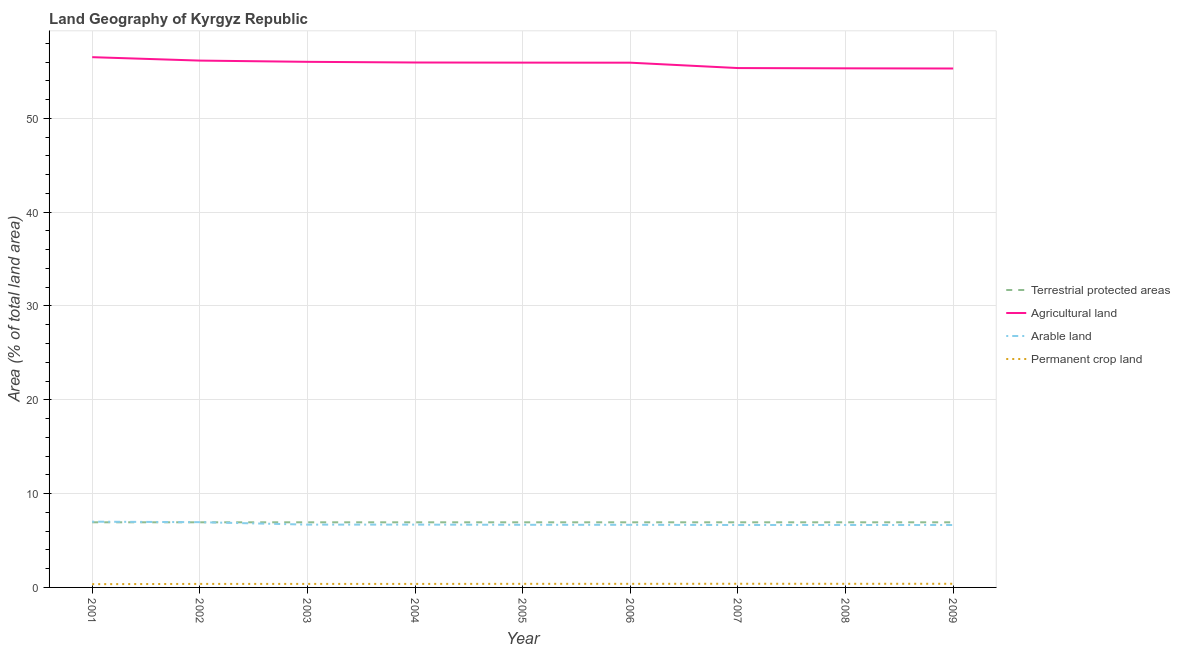How many different coloured lines are there?
Ensure brevity in your answer.  4. Is the number of lines equal to the number of legend labels?
Your response must be concise. Yes. What is the percentage of area under permanent crop land in 2006?
Offer a terse response. 0.38. Across all years, what is the maximum percentage of land under terrestrial protection?
Your answer should be very brief. 6.94. Across all years, what is the minimum percentage of area under arable land?
Your answer should be compact. 6.65. In which year was the percentage of area under permanent crop land maximum?
Make the answer very short. 2007. In which year was the percentage of area under arable land minimum?
Give a very brief answer. 2009. What is the total percentage of land under terrestrial protection in the graph?
Provide a short and direct response. 62.48. What is the difference between the percentage of area under arable land in 2005 and that in 2006?
Keep it short and to the point. 0. What is the difference between the percentage of area under permanent crop land in 2005 and the percentage of area under agricultural land in 2003?
Offer a terse response. -55.64. What is the average percentage of area under agricultural land per year?
Your answer should be compact. 55.83. In the year 2009, what is the difference between the percentage of land under terrestrial protection and percentage of area under arable land?
Your response must be concise. 0.29. In how many years, is the percentage of land under terrestrial protection greater than 18 %?
Offer a terse response. 0. What is the ratio of the percentage of area under arable land in 2001 to that in 2004?
Your answer should be compact. 1.05. Is the percentage of area under arable land in 2002 less than that in 2006?
Provide a succinct answer. No. What is the difference between the highest and the second highest percentage of land under terrestrial protection?
Your answer should be compact. 0. What is the difference between the highest and the lowest percentage of area under agricultural land?
Your answer should be compact. 1.21. In how many years, is the percentage of area under arable land greater than the average percentage of area under arable land taken over all years?
Your answer should be compact. 2. Is the sum of the percentage of land under terrestrial protection in 2001 and 2002 greater than the maximum percentage of area under arable land across all years?
Provide a short and direct response. Yes. Is it the case that in every year, the sum of the percentage of area under arable land and percentage of land under terrestrial protection is greater than the sum of percentage of area under permanent crop land and percentage of area under agricultural land?
Your answer should be very brief. No. Is it the case that in every year, the sum of the percentage of land under terrestrial protection and percentage of area under agricultural land is greater than the percentage of area under arable land?
Offer a very short reply. Yes. Is the percentage of area under agricultural land strictly greater than the percentage of land under terrestrial protection over the years?
Your response must be concise. Yes. Does the graph contain grids?
Your answer should be compact. Yes. What is the title of the graph?
Provide a succinct answer. Land Geography of Kyrgyz Republic. What is the label or title of the X-axis?
Give a very brief answer. Year. What is the label or title of the Y-axis?
Keep it short and to the point. Area (% of total land area). What is the Area (% of total land area) of Terrestrial protected areas in 2001?
Ensure brevity in your answer.  6.94. What is the Area (% of total land area) of Agricultural land in 2001?
Provide a short and direct response. 56.52. What is the Area (% of total land area) in Arable land in 2001?
Ensure brevity in your answer.  7.01. What is the Area (% of total land area) in Permanent crop land in 2001?
Offer a terse response. 0.35. What is the Area (% of total land area) of Terrestrial protected areas in 2002?
Your answer should be compact. 6.94. What is the Area (% of total land area) in Agricultural land in 2002?
Make the answer very short. 56.15. What is the Area (% of total land area) in Arable land in 2002?
Give a very brief answer. 6.96. What is the Area (% of total land area) of Permanent crop land in 2002?
Provide a short and direct response. 0.38. What is the Area (% of total land area) in Terrestrial protected areas in 2003?
Give a very brief answer. 6.94. What is the Area (% of total land area) in Agricultural land in 2003?
Make the answer very short. 56.02. What is the Area (% of total land area) of Arable land in 2003?
Provide a short and direct response. 6.69. What is the Area (% of total land area) in Permanent crop land in 2003?
Offer a terse response. 0.38. What is the Area (% of total land area) in Terrestrial protected areas in 2004?
Make the answer very short. 6.94. What is the Area (% of total land area) of Agricultural land in 2004?
Provide a short and direct response. 55.95. What is the Area (% of total land area) of Arable land in 2004?
Offer a very short reply. 6.69. What is the Area (% of total land area) of Permanent crop land in 2004?
Keep it short and to the point. 0.37. What is the Area (% of total land area) in Terrestrial protected areas in 2005?
Provide a succinct answer. 6.94. What is the Area (% of total land area) of Agricultural land in 2005?
Keep it short and to the point. 55.94. What is the Area (% of total land area) of Arable land in 2005?
Give a very brief answer. 6.67. What is the Area (% of total land area) of Permanent crop land in 2005?
Give a very brief answer. 0.38. What is the Area (% of total land area) of Terrestrial protected areas in 2006?
Ensure brevity in your answer.  6.94. What is the Area (% of total land area) of Agricultural land in 2006?
Your response must be concise. 55.93. What is the Area (% of total land area) of Arable land in 2006?
Offer a very short reply. 6.67. What is the Area (% of total land area) in Permanent crop land in 2006?
Offer a terse response. 0.38. What is the Area (% of total land area) in Terrestrial protected areas in 2007?
Make the answer very short. 6.94. What is the Area (% of total land area) of Agricultural land in 2007?
Give a very brief answer. 55.36. What is the Area (% of total land area) of Arable land in 2007?
Provide a short and direct response. 6.65. What is the Area (% of total land area) of Permanent crop land in 2007?
Give a very brief answer. 0.39. What is the Area (% of total land area) in Terrestrial protected areas in 2008?
Your response must be concise. 6.94. What is the Area (% of total land area) of Agricultural land in 2008?
Offer a terse response. 55.33. What is the Area (% of total land area) in Arable land in 2008?
Ensure brevity in your answer.  6.65. What is the Area (% of total land area) of Permanent crop land in 2008?
Offer a very short reply. 0.39. What is the Area (% of total land area) in Terrestrial protected areas in 2009?
Ensure brevity in your answer.  6.94. What is the Area (% of total land area) of Agricultural land in 2009?
Keep it short and to the point. 55.31. What is the Area (% of total land area) in Arable land in 2009?
Offer a terse response. 6.65. What is the Area (% of total land area) of Permanent crop land in 2009?
Offer a terse response. 0.39. Across all years, what is the maximum Area (% of total land area) of Terrestrial protected areas?
Offer a terse response. 6.94. Across all years, what is the maximum Area (% of total land area) of Agricultural land?
Make the answer very short. 56.52. Across all years, what is the maximum Area (% of total land area) of Arable land?
Offer a terse response. 7.01. Across all years, what is the maximum Area (% of total land area) in Permanent crop land?
Make the answer very short. 0.39. Across all years, what is the minimum Area (% of total land area) of Terrestrial protected areas?
Offer a terse response. 6.94. Across all years, what is the minimum Area (% of total land area) in Agricultural land?
Give a very brief answer. 55.31. Across all years, what is the minimum Area (% of total land area) in Arable land?
Your answer should be very brief. 6.65. Across all years, what is the minimum Area (% of total land area) in Permanent crop land?
Your answer should be very brief. 0.35. What is the total Area (% of total land area) of Terrestrial protected areas in the graph?
Your answer should be compact. 62.48. What is the total Area (% of total land area) of Agricultural land in the graph?
Your answer should be compact. 502.5. What is the total Area (% of total land area) of Arable land in the graph?
Keep it short and to the point. 60.65. What is the total Area (% of total land area) of Permanent crop land in the graph?
Provide a short and direct response. 3.41. What is the difference between the Area (% of total land area) in Agricultural land in 2001 and that in 2002?
Provide a short and direct response. 0.36. What is the difference between the Area (% of total land area) of Arable land in 2001 and that in 2002?
Give a very brief answer. 0.05. What is the difference between the Area (% of total land area) of Permanent crop land in 2001 and that in 2002?
Provide a short and direct response. -0.03. What is the difference between the Area (% of total land area) in Agricultural land in 2001 and that in 2003?
Give a very brief answer. 0.5. What is the difference between the Area (% of total land area) of Arable land in 2001 and that in 2003?
Your response must be concise. 0.31. What is the difference between the Area (% of total land area) in Permanent crop land in 2001 and that in 2003?
Your response must be concise. -0.03. What is the difference between the Area (% of total land area) in Terrestrial protected areas in 2001 and that in 2004?
Your response must be concise. 0. What is the difference between the Area (% of total land area) in Agricultural land in 2001 and that in 2004?
Keep it short and to the point. 0.57. What is the difference between the Area (% of total land area) of Arable land in 2001 and that in 2004?
Ensure brevity in your answer.  0.31. What is the difference between the Area (% of total land area) of Permanent crop land in 2001 and that in 2004?
Your response must be concise. -0.03. What is the difference between the Area (% of total land area) of Terrestrial protected areas in 2001 and that in 2005?
Your answer should be compact. 0. What is the difference between the Area (% of total land area) of Agricultural land in 2001 and that in 2005?
Make the answer very short. 0.58. What is the difference between the Area (% of total land area) in Arable land in 2001 and that in 2005?
Offer a very short reply. 0.33. What is the difference between the Area (% of total land area) of Permanent crop land in 2001 and that in 2005?
Your answer should be compact. -0.03. What is the difference between the Area (% of total land area) of Terrestrial protected areas in 2001 and that in 2006?
Make the answer very short. 0. What is the difference between the Area (% of total land area) in Agricultural land in 2001 and that in 2006?
Provide a short and direct response. 0.59. What is the difference between the Area (% of total land area) in Arable land in 2001 and that in 2006?
Make the answer very short. 0.34. What is the difference between the Area (% of total land area) in Permanent crop land in 2001 and that in 2006?
Offer a very short reply. -0.03. What is the difference between the Area (% of total land area) in Agricultural land in 2001 and that in 2007?
Make the answer very short. 1.16. What is the difference between the Area (% of total land area) in Arable land in 2001 and that in 2007?
Your answer should be very brief. 0.35. What is the difference between the Area (% of total land area) in Permanent crop land in 2001 and that in 2007?
Your answer should be compact. -0.04. What is the difference between the Area (% of total land area) in Agricultural land in 2001 and that in 2008?
Offer a very short reply. 1.19. What is the difference between the Area (% of total land area) in Arable land in 2001 and that in 2008?
Ensure brevity in your answer.  0.35. What is the difference between the Area (% of total land area) in Permanent crop land in 2001 and that in 2008?
Provide a short and direct response. -0.04. What is the difference between the Area (% of total land area) of Agricultural land in 2001 and that in 2009?
Provide a succinct answer. 1.21. What is the difference between the Area (% of total land area) in Arable land in 2001 and that in 2009?
Offer a very short reply. 0.36. What is the difference between the Area (% of total land area) in Permanent crop land in 2001 and that in 2009?
Ensure brevity in your answer.  -0.04. What is the difference between the Area (% of total land area) of Agricultural land in 2002 and that in 2003?
Provide a short and direct response. 0.13. What is the difference between the Area (% of total land area) in Arable land in 2002 and that in 2003?
Your response must be concise. 0.26. What is the difference between the Area (% of total land area) in Permanent crop land in 2002 and that in 2003?
Offer a very short reply. 0. What is the difference between the Area (% of total land area) of Agricultural land in 2002 and that in 2004?
Your answer should be very brief. 0.2. What is the difference between the Area (% of total land area) of Arable land in 2002 and that in 2004?
Offer a very short reply. 0.26. What is the difference between the Area (% of total land area) of Permanent crop land in 2002 and that in 2004?
Offer a very short reply. 0. What is the difference between the Area (% of total land area) of Agricultural land in 2002 and that in 2005?
Your answer should be very brief. 0.22. What is the difference between the Area (% of total land area) in Arable land in 2002 and that in 2005?
Ensure brevity in your answer.  0.28. What is the difference between the Area (% of total land area) in Permanent crop land in 2002 and that in 2005?
Make the answer very short. -0.01. What is the difference between the Area (% of total land area) in Agricultural land in 2002 and that in 2006?
Offer a very short reply. 0.22. What is the difference between the Area (% of total land area) in Arable land in 2002 and that in 2006?
Offer a terse response. 0.28. What is the difference between the Area (% of total land area) of Permanent crop land in 2002 and that in 2006?
Ensure brevity in your answer.  -0.01. What is the difference between the Area (% of total land area) in Terrestrial protected areas in 2002 and that in 2007?
Your response must be concise. 0. What is the difference between the Area (% of total land area) of Agricultural land in 2002 and that in 2007?
Keep it short and to the point. 0.8. What is the difference between the Area (% of total land area) of Arable land in 2002 and that in 2007?
Make the answer very short. 0.3. What is the difference between the Area (% of total land area) of Permanent crop land in 2002 and that in 2007?
Provide a short and direct response. -0.02. What is the difference between the Area (% of total land area) of Agricultural land in 2002 and that in 2008?
Provide a short and direct response. 0.82. What is the difference between the Area (% of total land area) of Arable land in 2002 and that in 2008?
Provide a succinct answer. 0.3. What is the difference between the Area (% of total land area) in Permanent crop land in 2002 and that in 2008?
Provide a succinct answer. -0.01. What is the difference between the Area (% of total land area) in Agricultural land in 2002 and that in 2009?
Keep it short and to the point. 0.84. What is the difference between the Area (% of total land area) in Arable land in 2002 and that in 2009?
Your answer should be compact. 0.3. What is the difference between the Area (% of total land area) in Permanent crop land in 2002 and that in 2009?
Offer a very short reply. -0.01. What is the difference between the Area (% of total land area) of Agricultural land in 2003 and that in 2004?
Give a very brief answer. 0.07. What is the difference between the Area (% of total land area) of Arable land in 2003 and that in 2004?
Your answer should be very brief. 0. What is the difference between the Area (% of total land area) of Permanent crop land in 2003 and that in 2004?
Provide a succinct answer. 0. What is the difference between the Area (% of total land area) in Agricultural land in 2003 and that in 2005?
Keep it short and to the point. 0.09. What is the difference between the Area (% of total land area) of Arable land in 2003 and that in 2005?
Offer a terse response. 0.02. What is the difference between the Area (% of total land area) in Permanent crop land in 2003 and that in 2005?
Provide a short and direct response. -0.01. What is the difference between the Area (% of total land area) in Terrestrial protected areas in 2003 and that in 2006?
Your answer should be compact. 0. What is the difference between the Area (% of total land area) in Agricultural land in 2003 and that in 2006?
Make the answer very short. 0.09. What is the difference between the Area (% of total land area) of Arable land in 2003 and that in 2006?
Provide a succinct answer. 0.02. What is the difference between the Area (% of total land area) in Permanent crop land in 2003 and that in 2006?
Provide a succinct answer. -0.01. What is the difference between the Area (% of total land area) in Agricultural land in 2003 and that in 2007?
Offer a terse response. 0.67. What is the difference between the Area (% of total land area) of Arable land in 2003 and that in 2007?
Offer a very short reply. 0.04. What is the difference between the Area (% of total land area) of Permanent crop land in 2003 and that in 2007?
Your answer should be compact. -0.02. What is the difference between the Area (% of total land area) of Terrestrial protected areas in 2003 and that in 2008?
Provide a short and direct response. 0. What is the difference between the Area (% of total land area) in Agricultural land in 2003 and that in 2008?
Your response must be concise. 0.69. What is the difference between the Area (% of total land area) in Arable land in 2003 and that in 2008?
Your answer should be very brief. 0.04. What is the difference between the Area (% of total land area) of Permanent crop land in 2003 and that in 2008?
Provide a succinct answer. -0.01. What is the difference between the Area (% of total land area) of Agricultural land in 2003 and that in 2009?
Your answer should be compact. 0.71. What is the difference between the Area (% of total land area) of Arable land in 2003 and that in 2009?
Offer a very short reply. 0.04. What is the difference between the Area (% of total land area) in Permanent crop land in 2003 and that in 2009?
Your answer should be very brief. -0.01. What is the difference between the Area (% of total land area) of Terrestrial protected areas in 2004 and that in 2005?
Provide a short and direct response. 0. What is the difference between the Area (% of total land area) in Agricultural land in 2004 and that in 2005?
Your response must be concise. 0.01. What is the difference between the Area (% of total land area) in Arable land in 2004 and that in 2005?
Your answer should be compact. 0.02. What is the difference between the Area (% of total land area) of Permanent crop land in 2004 and that in 2005?
Your answer should be very brief. -0.01. What is the difference between the Area (% of total land area) of Terrestrial protected areas in 2004 and that in 2006?
Offer a terse response. 0. What is the difference between the Area (% of total land area) in Agricultural land in 2004 and that in 2006?
Your response must be concise. 0.02. What is the difference between the Area (% of total land area) of Arable land in 2004 and that in 2006?
Provide a short and direct response. 0.02. What is the difference between the Area (% of total land area) of Permanent crop land in 2004 and that in 2006?
Give a very brief answer. -0.01. What is the difference between the Area (% of total land area) of Agricultural land in 2004 and that in 2007?
Provide a short and direct response. 0.59. What is the difference between the Area (% of total land area) of Arable land in 2004 and that in 2007?
Make the answer very short. 0.04. What is the difference between the Area (% of total land area) of Permanent crop land in 2004 and that in 2007?
Offer a terse response. -0.02. What is the difference between the Area (% of total land area) in Terrestrial protected areas in 2004 and that in 2008?
Give a very brief answer. 0. What is the difference between the Area (% of total land area) in Agricultural land in 2004 and that in 2008?
Offer a very short reply. 0.62. What is the difference between the Area (% of total land area) of Arable land in 2004 and that in 2008?
Provide a succinct answer. 0.04. What is the difference between the Area (% of total land area) in Permanent crop land in 2004 and that in 2008?
Provide a succinct answer. -0.01. What is the difference between the Area (% of total land area) of Agricultural land in 2004 and that in 2009?
Give a very brief answer. 0.64. What is the difference between the Area (% of total land area) in Arable land in 2004 and that in 2009?
Your response must be concise. 0.04. What is the difference between the Area (% of total land area) of Permanent crop land in 2004 and that in 2009?
Your response must be concise. -0.01. What is the difference between the Area (% of total land area) of Agricultural land in 2005 and that in 2006?
Ensure brevity in your answer.  0.01. What is the difference between the Area (% of total land area) of Arable land in 2005 and that in 2006?
Your answer should be compact. 0. What is the difference between the Area (% of total land area) of Permanent crop land in 2005 and that in 2006?
Give a very brief answer. 0. What is the difference between the Area (% of total land area) in Agricultural land in 2005 and that in 2007?
Offer a terse response. 0.58. What is the difference between the Area (% of total land area) of Arable land in 2005 and that in 2007?
Your response must be concise. 0.02. What is the difference between the Area (% of total land area) of Permanent crop land in 2005 and that in 2007?
Ensure brevity in your answer.  -0.01. What is the difference between the Area (% of total land area) of Agricultural land in 2005 and that in 2008?
Your answer should be compact. 0.61. What is the difference between the Area (% of total land area) of Arable land in 2005 and that in 2008?
Your answer should be very brief. 0.02. What is the difference between the Area (% of total land area) in Permanent crop land in 2005 and that in 2008?
Provide a short and direct response. -0. What is the difference between the Area (% of total land area) in Agricultural land in 2005 and that in 2009?
Your response must be concise. 0.63. What is the difference between the Area (% of total land area) of Arable land in 2005 and that in 2009?
Ensure brevity in your answer.  0.02. What is the difference between the Area (% of total land area) in Permanent crop land in 2005 and that in 2009?
Provide a short and direct response. -0.01. What is the difference between the Area (% of total land area) of Terrestrial protected areas in 2006 and that in 2007?
Offer a terse response. 0. What is the difference between the Area (% of total land area) of Agricultural land in 2006 and that in 2007?
Keep it short and to the point. 0.57. What is the difference between the Area (% of total land area) of Arable land in 2006 and that in 2007?
Your answer should be very brief. 0.02. What is the difference between the Area (% of total land area) of Permanent crop land in 2006 and that in 2007?
Your response must be concise. -0.01. What is the difference between the Area (% of total land area) in Agricultural land in 2006 and that in 2008?
Provide a short and direct response. 0.6. What is the difference between the Area (% of total land area) in Arable land in 2006 and that in 2008?
Make the answer very short. 0.02. What is the difference between the Area (% of total land area) of Permanent crop land in 2006 and that in 2008?
Give a very brief answer. -0. What is the difference between the Area (% of total land area) of Agricultural land in 2006 and that in 2009?
Provide a succinct answer. 0.62. What is the difference between the Area (% of total land area) of Arable land in 2006 and that in 2009?
Your response must be concise. 0.02. What is the difference between the Area (% of total land area) in Permanent crop land in 2006 and that in 2009?
Your answer should be compact. -0.01. What is the difference between the Area (% of total land area) in Agricultural land in 2007 and that in 2008?
Provide a succinct answer. 0.03. What is the difference between the Area (% of total land area) of Arable land in 2007 and that in 2008?
Your answer should be compact. -0. What is the difference between the Area (% of total land area) of Permanent crop land in 2007 and that in 2008?
Keep it short and to the point. 0. What is the difference between the Area (% of total land area) of Agricultural land in 2007 and that in 2009?
Keep it short and to the point. 0.05. What is the difference between the Area (% of total land area) of Permanent crop land in 2007 and that in 2009?
Provide a succinct answer. 0. What is the difference between the Area (% of total land area) of Agricultural land in 2008 and that in 2009?
Offer a very short reply. 0.02. What is the difference between the Area (% of total land area) of Arable land in 2008 and that in 2009?
Provide a short and direct response. 0. What is the difference between the Area (% of total land area) in Permanent crop land in 2008 and that in 2009?
Keep it short and to the point. -0. What is the difference between the Area (% of total land area) of Terrestrial protected areas in 2001 and the Area (% of total land area) of Agricultural land in 2002?
Your answer should be very brief. -49.21. What is the difference between the Area (% of total land area) of Terrestrial protected areas in 2001 and the Area (% of total land area) of Arable land in 2002?
Your answer should be very brief. -0.01. What is the difference between the Area (% of total land area) in Terrestrial protected areas in 2001 and the Area (% of total land area) in Permanent crop land in 2002?
Offer a terse response. 6.57. What is the difference between the Area (% of total land area) in Agricultural land in 2001 and the Area (% of total land area) in Arable land in 2002?
Your answer should be very brief. 49.56. What is the difference between the Area (% of total land area) in Agricultural land in 2001 and the Area (% of total land area) in Permanent crop land in 2002?
Offer a very short reply. 56.14. What is the difference between the Area (% of total land area) of Arable land in 2001 and the Area (% of total land area) of Permanent crop land in 2002?
Offer a very short reply. 6.63. What is the difference between the Area (% of total land area) of Terrestrial protected areas in 2001 and the Area (% of total land area) of Agricultural land in 2003?
Provide a short and direct response. -49.08. What is the difference between the Area (% of total land area) of Terrestrial protected areas in 2001 and the Area (% of total land area) of Arable land in 2003?
Your response must be concise. 0.25. What is the difference between the Area (% of total land area) of Terrestrial protected areas in 2001 and the Area (% of total land area) of Permanent crop land in 2003?
Provide a succinct answer. 6.57. What is the difference between the Area (% of total land area) in Agricultural land in 2001 and the Area (% of total land area) in Arable land in 2003?
Provide a short and direct response. 49.82. What is the difference between the Area (% of total land area) in Agricultural land in 2001 and the Area (% of total land area) in Permanent crop land in 2003?
Make the answer very short. 56.14. What is the difference between the Area (% of total land area) of Arable land in 2001 and the Area (% of total land area) of Permanent crop land in 2003?
Offer a terse response. 6.63. What is the difference between the Area (% of total land area) of Terrestrial protected areas in 2001 and the Area (% of total land area) of Agricultural land in 2004?
Provide a succinct answer. -49.01. What is the difference between the Area (% of total land area) of Terrestrial protected areas in 2001 and the Area (% of total land area) of Arable land in 2004?
Offer a terse response. 0.25. What is the difference between the Area (% of total land area) in Terrestrial protected areas in 2001 and the Area (% of total land area) in Permanent crop land in 2004?
Keep it short and to the point. 6.57. What is the difference between the Area (% of total land area) of Agricultural land in 2001 and the Area (% of total land area) of Arable land in 2004?
Your answer should be compact. 49.82. What is the difference between the Area (% of total land area) in Agricultural land in 2001 and the Area (% of total land area) in Permanent crop land in 2004?
Offer a terse response. 56.14. What is the difference between the Area (% of total land area) in Arable land in 2001 and the Area (% of total land area) in Permanent crop land in 2004?
Make the answer very short. 6.63. What is the difference between the Area (% of total land area) of Terrestrial protected areas in 2001 and the Area (% of total land area) of Agricultural land in 2005?
Provide a succinct answer. -48.99. What is the difference between the Area (% of total land area) of Terrestrial protected areas in 2001 and the Area (% of total land area) of Arable land in 2005?
Your response must be concise. 0.27. What is the difference between the Area (% of total land area) in Terrestrial protected areas in 2001 and the Area (% of total land area) in Permanent crop land in 2005?
Make the answer very short. 6.56. What is the difference between the Area (% of total land area) of Agricultural land in 2001 and the Area (% of total land area) of Arable land in 2005?
Ensure brevity in your answer.  49.84. What is the difference between the Area (% of total land area) of Agricultural land in 2001 and the Area (% of total land area) of Permanent crop land in 2005?
Ensure brevity in your answer.  56.13. What is the difference between the Area (% of total land area) in Arable land in 2001 and the Area (% of total land area) in Permanent crop land in 2005?
Offer a terse response. 6.62. What is the difference between the Area (% of total land area) in Terrestrial protected areas in 2001 and the Area (% of total land area) in Agricultural land in 2006?
Give a very brief answer. -48.99. What is the difference between the Area (% of total land area) in Terrestrial protected areas in 2001 and the Area (% of total land area) in Arable land in 2006?
Ensure brevity in your answer.  0.27. What is the difference between the Area (% of total land area) in Terrestrial protected areas in 2001 and the Area (% of total land area) in Permanent crop land in 2006?
Your response must be concise. 6.56. What is the difference between the Area (% of total land area) of Agricultural land in 2001 and the Area (% of total land area) of Arable land in 2006?
Offer a terse response. 49.85. What is the difference between the Area (% of total land area) in Agricultural land in 2001 and the Area (% of total land area) in Permanent crop land in 2006?
Your response must be concise. 56.13. What is the difference between the Area (% of total land area) in Arable land in 2001 and the Area (% of total land area) in Permanent crop land in 2006?
Offer a very short reply. 6.62. What is the difference between the Area (% of total land area) in Terrestrial protected areas in 2001 and the Area (% of total land area) in Agricultural land in 2007?
Your answer should be compact. -48.41. What is the difference between the Area (% of total land area) of Terrestrial protected areas in 2001 and the Area (% of total land area) of Arable land in 2007?
Your answer should be compact. 0.29. What is the difference between the Area (% of total land area) of Terrestrial protected areas in 2001 and the Area (% of total land area) of Permanent crop land in 2007?
Your answer should be compact. 6.55. What is the difference between the Area (% of total land area) in Agricultural land in 2001 and the Area (% of total land area) in Arable land in 2007?
Your response must be concise. 49.86. What is the difference between the Area (% of total land area) in Agricultural land in 2001 and the Area (% of total land area) in Permanent crop land in 2007?
Offer a very short reply. 56.13. What is the difference between the Area (% of total land area) of Arable land in 2001 and the Area (% of total land area) of Permanent crop land in 2007?
Provide a short and direct response. 6.62. What is the difference between the Area (% of total land area) in Terrestrial protected areas in 2001 and the Area (% of total land area) in Agricultural land in 2008?
Ensure brevity in your answer.  -48.39. What is the difference between the Area (% of total land area) of Terrestrial protected areas in 2001 and the Area (% of total land area) of Arable land in 2008?
Give a very brief answer. 0.29. What is the difference between the Area (% of total land area) of Terrestrial protected areas in 2001 and the Area (% of total land area) of Permanent crop land in 2008?
Make the answer very short. 6.55. What is the difference between the Area (% of total land area) in Agricultural land in 2001 and the Area (% of total land area) in Arable land in 2008?
Offer a terse response. 49.86. What is the difference between the Area (% of total land area) in Agricultural land in 2001 and the Area (% of total land area) in Permanent crop land in 2008?
Provide a short and direct response. 56.13. What is the difference between the Area (% of total land area) in Arable land in 2001 and the Area (% of total land area) in Permanent crop land in 2008?
Make the answer very short. 6.62. What is the difference between the Area (% of total land area) of Terrestrial protected areas in 2001 and the Area (% of total land area) of Agricultural land in 2009?
Offer a very short reply. -48.37. What is the difference between the Area (% of total land area) of Terrestrial protected areas in 2001 and the Area (% of total land area) of Arable land in 2009?
Your answer should be very brief. 0.29. What is the difference between the Area (% of total land area) of Terrestrial protected areas in 2001 and the Area (% of total land area) of Permanent crop land in 2009?
Your answer should be very brief. 6.55. What is the difference between the Area (% of total land area) in Agricultural land in 2001 and the Area (% of total land area) in Arable land in 2009?
Your answer should be compact. 49.87. What is the difference between the Area (% of total land area) of Agricultural land in 2001 and the Area (% of total land area) of Permanent crop land in 2009?
Make the answer very short. 56.13. What is the difference between the Area (% of total land area) of Arable land in 2001 and the Area (% of total land area) of Permanent crop land in 2009?
Offer a very short reply. 6.62. What is the difference between the Area (% of total land area) in Terrestrial protected areas in 2002 and the Area (% of total land area) in Agricultural land in 2003?
Give a very brief answer. -49.08. What is the difference between the Area (% of total land area) of Terrestrial protected areas in 2002 and the Area (% of total land area) of Arable land in 2003?
Offer a terse response. 0.25. What is the difference between the Area (% of total land area) in Terrestrial protected areas in 2002 and the Area (% of total land area) in Permanent crop land in 2003?
Provide a short and direct response. 6.57. What is the difference between the Area (% of total land area) of Agricultural land in 2002 and the Area (% of total land area) of Arable land in 2003?
Provide a short and direct response. 49.46. What is the difference between the Area (% of total land area) in Agricultural land in 2002 and the Area (% of total land area) in Permanent crop land in 2003?
Ensure brevity in your answer.  55.78. What is the difference between the Area (% of total land area) in Arable land in 2002 and the Area (% of total land area) in Permanent crop land in 2003?
Offer a very short reply. 6.58. What is the difference between the Area (% of total land area) of Terrestrial protected areas in 2002 and the Area (% of total land area) of Agricultural land in 2004?
Your response must be concise. -49.01. What is the difference between the Area (% of total land area) in Terrestrial protected areas in 2002 and the Area (% of total land area) in Arable land in 2004?
Your answer should be compact. 0.25. What is the difference between the Area (% of total land area) in Terrestrial protected areas in 2002 and the Area (% of total land area) in Permanent crop land in 2004?
Provide a short and direct response. 6.57. What is the difference between the Area (% of total land area) of Agricultural land in 2002 and the Area (% of total land area) of Arable land in 2004?
Make the answer very short. 49.46. What is the difference between the Area (% of total land area) in Agricultural land in 2002 and the Area (% of total land area) in Permanent crop land in 2004?
Provide a short and direct response. 55.78. What is the difference between the Area (% of total land area) in Arable land in 2002 and the Area (% of total land area) in Permanent crop land in 2004?
Your answer should be compact. 6.58. What is the difference between the Area (% of total land area) in Terrestrial protected areas in 2002 and the Area (% of total land area) in Agricultural land in 2005?
Your response must be concise. -48.99. What is the difference between the Area (% of total land area) of Terrestrial protected areas in 2002 and the Area (% of total land area) of Arable land in 2005?
Ensure brevity in your answer.  0.27. What is the difference between the Area (% of total land area) of Terrestrial protected areas in 2002 and the Area (% of total land area) of Permanent crop land in 2005?
Provide a short and direct response. 6.56. What is the difference between the Area (% of total land area) in Agricultural land in 2002 and the Area (% of total land area) in Arable land in 2005?
Your answer should be compact. 49.48. What is the difference between the Area (% of total land area) of Agricultural land in 2002 and the Area (% of total land area) of Permanent crop land in 2005?
Provide a succinct answer. 55.77. What is the difference between the Area (% of total land area) in Arable land in 2002 and the Area (% of total land area) in Permanent crop land in 2005?
Your answer should be very brief. 6.57. What is the difference between the Area (% of total land area) in Terrestrial protected areas in 2002 and the Area (% of total land area) in Agricultural land in 2006?
Keep it short and to the point. -48.99. What is the difference between the Area (% of total land area) of Terrestrial protected areas in 2002 and the Area (% of total land area) of Arable land in 2006?
Provide a succinct answer. 0.27. What is the difference between the Area (% of total land area) of Terrestrial protected areas in 2002 and the Area (% of total land area) of Permanent crop land in 2006?
Make the answer very short. 6.56. What is the difference between the Area (% of total land area) of Agricultural land in 2002 and the Area (% of total land area) of Arable land in 2006?
Give a very brief answer. 49.48. What is the difference between the Area (% of total land area) in Agricultural land in 2002 and the Area (% of total land area) in Permanent crop land in 2006?
Your answer should be very brief. 55.77. What is the difference between the Area (% of total land area) of Arable land in 2002 and the Area (% of total land area) of Permanent crop land in 2006?
Ensure brevity in your answer.  6.57. What is the difference between the Area (% of total land area) of Terrestrial protected areas in 2002 and the Area (% of total land area) of Agricultural land in 2007?
Offer a very short reply. -48.41. What is the difference between the Area (% of total land area) of Terrestrial protected areas in 2002 and the Area (% of total land area) of Arable land in 2007?
Give a very brief answer. 0.29. What is the difference between the Area (% of total land area) in Terrestrial protected areas in 2002 and the Area (% of total land area) in Permanent crop land in 2007?
Your answer should be compact. 6.55. What is the difference between the Area (% of total land area) in Agricultural land in 2002 and the Area (% of total land area) in Arable land in 2007?
Your answer should be compact. 49.5. What is the difference between the Area (% of total land area) of Agricultural land in 2002 and the Area (% of total land area) of Permanent crop land in 2007?
Give a very brief answer. 55.76. What is the difference between the Area (% of total land area) in Arable land in 2002 and the Area (% of total land area) in Permanent crop land in 2007?
Offer a terse response. 6.56. What is the difference between the Area (% of total land area) of Terrestrial protected areas in 2002 and the Area (% of total land area) of Agricultural land in 2008?
Keep it short and to the point. -48.39. What is the difference between the Area (% of total land area) of Terrestrial protected areas in 2002 and the Area (% of total land area) of Arable land in 2008?
Provide a succinct answer. 0.29. What is the difference between the Area (% of total land area) in Terrestrial protected areas in 2002 and the Area (% of total land area) in Permanent crop land in 2008?
Make the answer very short. 6.55. What is the difference between the Area (% of total land area) in Agricultural land in 2002 and the Area (% of total land area) in Arable land in 2008?
Offer a very short reply. 49.5. What is the difference between the Area (% of total land area) in Agricultural land in 2002 and the Area (% of total land area) in Permanent crop land in 2008?
Your answer should be very brief. 55.77. What is the difference between the Area (% of total land area) in Arable land in 2002 and the Area (% of total land area) in Permanent crop land in 2008?
Keep it short and to the point. 6.57. What is the difference between the Area (% of total land area) of Terrestrial protected areas in 2002 and the Area (% of total land area) of Agricultural land in 2009?
Keep it short and to the point. -48.37. What is the difference between the Area (% of total land area) in Terrestrial protected areas in 2002 and the Area (% of total land area) in Arable land in 2009?
Your answer should be compact. 0.29. What is the difference between the Area (% of total land area) in Terrestrial protected areas in 2002 and the Area (% of total land area) in Permanent crop land in 2009?
Your response must be concise. 6.55. What is the difference between the Area (% of total land area) of Agricultural land in 2002 and the Area (% of total land area) of Arable land in 2009?
Your answer should be very brief. 49.5. What is the difference between the Area (% of total land area) in Agricultural land in 2002 and the Area (% of total land area) in Permanent crop land in 2009?
Offer a very short reply. 55.76. What is the difference between the Area (% of total land area) in Arable land in 2002 and the Area (% of total land area) in Permanent crop land in 2009?
Keep it short and to the point. 6.57. What is the difference between the Area (% of total land area) in Terrestrial protected areas in 2003 and the Area (% of total land area) in Agricultural land in 2004?
Your response must be concise. -49.01. What is the difference between the Area (% of total land area) in Terrestrial protected areas in 2003 and the Area (% of total land area) in Arable land in 2004?
Keep it short and to the point. 0.25. What is the difference between the Area (% of total land area) in Terrestrial protected areas in 2003 and the Area (% of total land area) in Permanent crop land in 2004?
Offer a terse response. 6.57. What is the difference between the Area (% of total land area) of Agricultural land in 2003 and the Area (% of total land area) of Arable land in 2004?
Give a very brief answer. 49.33. What is the difference between the Area (% of total land area) in Agricultural land in 2003 and the Area (% of total land area) in Permanent crop land in 2004?
Provide a succinct answer. 55.65. What is the difference between the Area (% of total land area) of Arable land in 2003 and the Area (% of total land area) of Permanent crop land in 2004?
Give a very brief answer. 6.32. What is the difference between the Area (% of total land area) of Terrestrial protected areas in 2003 and the Area (% of total land area) of Agricultural land in 2005?
Offer a terse response. -48.99. What is the difference between the Area (% of total land area) of Terrestrial protected areas in 2003 and the Area (% of total land area) of Arable land in 2005?
Offer a terse response. 0.27. What is the difference between the Area (% of total land area) in Terrestrial protected areas in 2003 and the Area (% of total land area) in Permanent crop land in 2005?
Your answer should be compact. 6.56. What is the difference between the Area (% of total land area) of Agricultural land in 2003 and the Area (% of total land area) of Arable land in 2005?
Provide a short and direct response. 49.35. What is the difference between the Area (% of total land area) of Agricultural land in 2003 and the Area (% of total land area) of Permanent crop land in 2005?
Provide a short and direct response. 55.64. What is the difference between the Area (% of total land area) of Arable land in 2003 and the Area (% of total land area) of Permanent crop land in 2005?
Ensure brevity in your answer.  6.31. What is the difference between the Area (% of total land area) of Terrestrial protected areas in 2003 and the Area (% of total land area) of Agricultural land in 2006?
Give a very brief answer. -48.99. What is the difference between the Area (% of total land area) of Terrestrial protected areas in 2003 and the Area (% of total land area) of Arable land in 2006?
Your answer should be compact. 0.27. What is the difference between the Area (% of total land area) in Terrestrial protected areas in 2003 and the Area (% of total land area) in Permanent crop land in 2006?
Ensure brevity in your answer.  6.56. What is the difference between the Area (% of total land area) of Agricultural land in 2003 and the Area (% of total land area) of Arable land in 2006?
Make the answer very short. 49.35. What is the difference between the Area (% of total land area) of Agricultural land in 2003 and the Area (% of total land area) of Permanent crop land in 2006?
Offer a very short reply. 55.64. What is the difference between the Area (% of total land area) in Arable land in 2003 and the Area (% of total land area) in Permanent crop land in 2006?
Your answer should be compact. 6.31. What is the difference between the Area (% of total land area) in Terrestrial protected areas in 2003 and the Area (% of total land area) in Agricultural land in 2007?
Provide a short and direct response. -48.41. What is the difference between the Area (% of total land area) of Terrestrial protected areas in 2003 and the Area (% of total land area) of Arable land in 2007?
Provide a succinct answer. 0.29. What is the difference between the Area (% of total land area) in Terrestrial protected areas in 2003 and the Area (% of total land area) in Permanent crop land in 2007?
Provide a succinct answer. 6.55. What is the difference between the Area (% of total land area) in Agricultural land in 2003 and the Area (% of total land area) in Arable land in 2007?
Offer a terse response. 49.37. What is the difference between the Area (% of total land area) in Agricultural land in 2003 and the Area (% of total land area) in Permanent crop land in 2007?
Your response must be concise. 55.63. What is the difference between the Area (% of total land area) in Arable land in 2003 and the Area (% of total land area) in Permanent crop land in 2007?
Offer a terse response. 6.3. What is the difference between the Area (% of total land area) in Terrestrial protected areas in 2003 and the Area (% of total land area) in Agricultural land in 2008?
Your answer should be very brief. -48.39. What is the difference between the Area (% of total land area) in Terrestrial protected areas in 2003 and the Area (% of total land area) in Arable land in 2008?
Offer a very short reply. 0.29. What is the difference between the Area (% of total land area) in Terrestrial protected areas in 2003 and the Area (% of total land area) in Permanent crop land in 2008?
Your answer should be compact. 6.55. What is the difference between the Area (% of total land area) of Agricultural land in 2003 and the Area (% of total land area) of Arable land in 2008?
Provide a short and direct response. 49.37. What is the difference between the Area (% of total land area) of Agricultural land in 2003 and the Area (% of total land area) of Permanent crop land in 2008?
Provide a short and direct response. 55.63. What is the difference between the Area (% of total land area) in Arable land in 2003 and the Area (% of total land area) in Permanent crop land in 2008?
Make the answer very short. 6.31. What is the difference between the Area (% of total land area) of Terrestrial protected areas in 2003 and the Area (% of total land area) of Agricultural land in 2009?
Your response must be concise. -48.37. What is the difference between the Area (% of total land area) in Terrestrial protected areas in 2003 and the Area (% of total land area) in Arable land in 2009?
Make the answer very short. 0.29. What is the difference between the Area (% of total land area) in Terrestrial protected areas in 2003 and the Area (% of total land area) in Permanent crop land in 2009?
Make the answer very short. 6.55. What is the difference between the Area (% of total land area) in Agricultural land in 2003 and the Area (% of total land area) in Arable land in 2009?
Your response must be concise. 49.37. What is the difference between the Area (% of total land area) of Agricultural land in 2003 and the Area (% of total land area) of Permanent crop land in 2009?
Offer a terse response. 55.63. What is the difference between the Area (% of total land area) in Arable land in 2003 and the Area (% of total land area) in Permanent crop land in 2009?
Offer a terse response. 6.3. What is the difference between the Area (% of total land area) in Terrestrial protected areas in 2004 and the Area (% of total land area) in Agricultural land in 2005?
Provide a succinct answer. -48.99. What is the difference between the Area (% of total land area) in Terrestrial protected areas in 2004 and the Area (% of total land area) in Arable land in 2005?
Offer a terse response. 0.27. What is the difference between the Area (% of total land area) in Terrestrial protected areas in 2004 and the Area (% of total land area) in Permanent crop land in 2005?
Provide a succinct answer. 6.56. What is the difference between the Area (% of total land area) of Agricultural land in 2004 and the Area (% of total land area) of Arable land in 2005?
Your response must be concise. 49.28. What is the difference between the Area (% of total land area) in Agricultural land in 2004 and the Area (% of total land area) in Permanent crop land in 2005?
Offer a very short reply. 55.57. What is the difference between the Area (% of total land area) in Arable land in 2004 and the Area (% of total land area) in Permanent crop land in 2005?
Provide a short and direct response. 6.31. What is the difference between the Area (% of total land area) in Terrestrial protected areas in 2004 and the Area (% of total land area) in Agricultural land in 2006?
Ensure brevity in your answer.  -48.99. What is the difference between the Area (% of total land area) of Terrestrial protected areas in 2004 and the Area (% of total land area) of Arable land in 2006?
Offer a very short reply. 0.27. What is the difference between the Area (% of total land area) in Terrestrial protected areas in 2004 and the Area (% of total land area) in Permanent crop land in 2006?
Make the answer very short. 6.56. What is the difference between the Area (% of total land area) of Agricultural land in 2004 and the Area (% of total land area) of Arable land in 2006?
Your answer should be compact. 49.28. What is the difference between the Area (% of total land area) in Agricultural land in 2004 and the Area (% of total land area) in Permanent crop land in 2006?
Offer a very short reply. 55.57. What is the difference between the Area (% of total land area) in Arable land in 2004 and the Area (% of total land area) in Permanent crop land in 2006?
Ensure brevity in your answer.  6.31. What is the difference between the Area (% of total land area) in Terrestrial protected areas in 2004 and the Area (% of total land area) in Agricultural land in 2007?
Make the answer very short. -48.41. What is the difference between the Area (% of total land area) of Terrestrial protected areas in 2004 and the Area (% of total land area) of Arable land in 2007?
Ensure brevity in your answer.  0.29. What is the difference between the Area (% of total land area) in Terrestrial protected areas in 2004 and the Area (% of total land area) in Permanent crop land in 2007?
Your answer should be very brief. 6.55. What is the difference between the Area (% of total land area) in Agricultural land in 2004 and the Area (% of total land area) in Arable land in 2007?
Make the answer very short. 49.3. What is the difference between the Area (% of total land area) of Agricultural land in 2004 and the Area (% of total land area) of Permanent crop land in 2007?
Your response must be concise. 55.56. What is the difference between the Area (% of total land area) of Arable land in 2004 and the Area (% of total land area) of Permanent crop land in 2007?
Offer a terse response. 6.3. What is the difference between the Area (% of total land area) of Terrestrial protected areas in 2004 and the Area (% of total land area) of Agricultural land in 2008?
Offer a terse response. -48.39. What is the difference between the Area (% of total land area) in Terrestrial protected areas in 2004 and the Area (% of total land area) in Arable land in 2008?
Provide a short and direct response. 0.29. What is the difference between the Area (% of total land area) in Terrestrial protected areas in 2004 and the Area (% of total land area) in Permanent crop land in 2008?
Ensure brevity in your answer.  6.55. What is the difference between the Area (% of total land area) of Agricultural land in 2004 and the Area (% of total land area) of Arable land in 2008?
Make the answer very short. 49.3. What is the difference between the Area (% of total land area) in Agricultural land in 2004 and the Area (% of total land area) in Permanent crop land in 2008?
Keep it short and to the point. 55.56. What is the difference between the Area (% of total land area) in Arable land in 2004 and the Area (% of total land area) in Permanent crop land in 2008?
Your answer should be very brief. 6.31. What is the difference between the Area (% of total land area) in Terrestrial protected areas in 2004 and the Area (% of total land area) in Agricultural land in 2009?
Offer a very short reply. -48.37. What is the difference between the Area (% of total land area) in Terrestrial protected areas in 2004 and the Area (% of total land area) in Arable land in 2009?
Keep it short and to the point. 0.29. What is the difference between the Area (% of total land area) in Terrestrial protected areas in 2004 and the Area (% of total land area) in Permanent crop land in 2009?
Your response must be concise. 6.55. What is the difference between the Area (% of total land area) of Agricultural land in 2004 and the Area (% of total land area) of Arable land in 2009?
Make the answer very short. 49.3. What is the difference between the Area (% of total land area) of Agricultural land in 2004 and the Area (% of total land area) of Permanent crop land in 2009?
Offer a very short reply. 55.56. What is the difference between the Area (% of total land area) in Arable land in 2004 and the Area (% of total land area) in Permanent crop land in 2009?
Offer a very short reply. 6.3. What is the difference between the Area (% of total land area) of Terrestrial protected areas in 2005 and the Area (% of total land area) of Agricultural land in 2006?
Ensure brevity in your answer.  -48.99. What is the difference between the Area (% of total land area) of Terrestrial protected areas in 2005 and the Area (% of total land area) of Arable land in 2006?
Provide a succinct answer. 0.27. What is the difference between the Area (% of total land area) of Terrestrial protected areas in 2005 and the Area (% of total land area) of Permanent crop land in 2006?
Your answer should be compact. 6.56. What is the difference between the Area (% of total land area) in Agricultural land in 2005 and the Area (% of total land area) in Arable land in 2006?
Offer a terse response. 49.27. What is the difference between the Area (% of total land area) of Agricultural land in 2005 and the Area (% of total land area) of Permanent crop land in 2006?
Offer a terse response. 55.55. What is the difference between the Area (% of total land area) in Arable land in 2005 and the Area (% of total land area) in Permanent crop land in 2006?
Offer a terse response. 6.29. What is the difference between the Area (% of total land area) in Terrestrial protected areas in 2005 and the Area (% of total land area) in Agricultural land in 2007?
Make the answer very short. -48.41. What is the difference between the Area (% of total land area) in Terrestrial protected areas in 2005 and the Area (% of total land area) in Arable land in 2007?
Ensure brevity in your answer.  0.29. What is the difference between the Area (% of total land area) of Terrestrial protected areas in 2005 and the Area (% of total land area) of Permanent crop land in 2007?
Offer a very short reply. 6.55. What is the difference between the Area (% of total land area) in Agricultural land in 2005 and the Area (% of total land area) in Arable land in 2007?
Offer a very short reply. 49.28. What is the difference between the Area (% of total land area) of Agricultural land in 2005 and the Area (% of total land area) of Permanent crop land in 2007?
Offer a very short reply. 55.55. What is the difference between the Area (% of total land area) in Arable land in 2005 and the Area (% of total land area) in Permanent crop land in 2007?
Provide a succinct answer. 6.28. What is the difference between the Area (% of total land area) of Terrestrial protected areas in 2005 and the Area (% of total land area) of Agricultural land in 2008?
Offer a terse response. -48.39. What is the difference between the Area (% of total land area) of Terrestrial protected areas in 2005 and the Area (% of total land area) of Arable land in 2008?
Give a very brief answer. 0.29. What is the difference between the Area (% of total land area) in Terrestrial protected areas in 2005 and the Area (% of total land area) in Permanent crop land in 2008?
Your response must be concise. 6.55. What is the difference between the Area (% of total land area) of Agricultural land in 2005 and the Area (% of total land area) of Arable land in 2008?
Your answer should be very brief. 49.28. What is the difference between the Area (% of total land area) of Agricultural land in 2005 and the Area (% of total land area) of Permanent crop land in 2008?
Offer a terse response. 55.55. What is the difference between the Area (% of total land area) in Arable land in 2005 and the Area (% of total land area) in Permanent crop land in 2008?
Provide a succinct answer. 6.29. What is the difference between the Area (% of total land area) of Terrestrial protected areas in 2005 and the Area (% of total land area) of Agricultural land in 2009?
Keep it short and to the point. -48.37. What is the difference between the Area (% of total land area) of Terrestrial protected areas in 2005 and the Area (% of total land area) of Arable land in 2009?
Provide a short and direct response. 0.29. What is the difference between the Area (% of total land area) of Terrestrial protected areas in 2005 and the Area (% of total land area) of Permanent crop land in 2009?
Ensure brevity in your answer.  6.55. What is the difference between the Area (% of total land area) in Agricultural land in 2005 and the Area (% of total land area) in Arable land in 2009?
Your answer should be compact. 49.28. What is the difference between the Area (% of total land area) in Agricultural land in 2005 and the Area (% of total land area) in Permanent crop land in 2009?
Provide a succinct answer. 55.55. What is the difference between the Area (% of total land area) in Arable land in 2005 and the Area (% of total land area) in Permanent crop land in 2009?
Your answer should be compact. 6.28. What is the difference between the Area (% of total land area) in Terrestrial protected areas in 2006 and the Area (% of total land area) in Agricultural land in 2007?
Make the answer very short. -48.41. What is the difference between the Area (% of total land area) of Terrestrial protected areas in 2006 and the Area (% of total land area) of Arable land in 2007?
Your answer should be very brief. 0.29. What is the difference between the Area (% of total land area) of Terrestrial protected areas in 2006 and the Area (% of total land area) of Permanent crop land in 2007?
Your response must be concise. 6.55. What is the difference between the Area (% of total land area) of Agricultural land in 2006 and the Area (% of total land area) of Arable land in 2007?
Keep it short and to the point. 49.28. What is the difference between the Area (% of total land area) in Agricultural land in 2006 and the Area (% of total land area) in Permanent crop land in 2007?
Provide a short and direct response. 55.54. What is the difference between the Area (% of total land area) in Arable land in 2006 and the Area (% of total land area) in Permanent crop land in 2007?
Your answer should be compact. 6.28. What is the difference between the Area (% of total land area) of Terrestrial protected areas in 2006 and the Area (% of total land area) of Agricultural land in 2008?
Your answer should be very brief. -48.39. What is the difference between the Area (% of total land area) of Terrestrial protected areas in 2006 and the Area (% of total land area) of Arable land in 2008?
Keep it short and to the point. 0.29. What is the difference between the Area (% of total land area) in Terrestrial protected areas in 2006 and the Area (% of total land area) in Permanent crop land in 2008?
Make the answer very short. 6.55. What is the difference between the Area (% of total land area) of Agricultural land in 2006 and the Area (% of total land area) of Arable land in 2008?
Provide a succinct answer. 49.28. What is the difference between the Area (% of total land area) in Agricultural land in 2006 and the Area (% of total land area) in Permanent crop land in 2008?
Provide a succinct answer. 55.54. What is the difference between the Area (% of total land area) in Arable land in 2006 and the Area (% of total land area) in Permanent crop land in 2008?
Ensure brevity in your answer.  6.28. What is the difference between the Area (% of total land area) of Terrestrial protected areas in 2006 and the Area (% of total land area) of Agricultural land in 2009?
Offer a terse response. -48.37. What is the difference between the Area (% of total land area) of Terrestrial protected areas in 2006 and the Area (% of total land area) of Arable land in 2009?
Your answer should be very brief. 0.29. What is the difference between the Area (% of total land area) of Terrestrial protected areas in 2006 and the Area (% of total land area) of Permanent crop land in 2009?
Your answer should be very brief. 6.55. What is the difference between the Area (% of total land area) in Agricultural land in 2006 and the Area (% of total land area) in Arable land in 2009?
Your answer should be compact. 49.28. What is the difference between the Area (% of total land area) of Agricultural land in 2006 and the Area (% of total land area) of Permanent crop land in 2009?
Ensure brevity in your answer.  55.54. What is the difference between the Area (% of total land area) in Arable land in 2006 and the Area (% of total land area) in Permanent crop land in 2009?
Give a very brief answer. 6.28. What is the difference between the Area (% of total land area) of Terrestrial protected areas in 2007 and the Area (% of total land area) of Agricultural land in 2008?
Provide a succinct answer. -48.39. What is the difference between the Area (% of total land area) of Terrestrial protected areas in 2007 and the Area (% of total land area) of Arable land in 2008?
Provide a succinct answer. 0.29. What is the difference between the Area (% of total land area) in Terrestrial protected areas in 2007 and the Area (% of total land area) in Permanent crop land in 2008?
Keep it short and to the point. 6.55. What is the difference between the Area (% of total land area) of Agricultural land in 2007 and the Area (% of total land area) of Arable land in 2008?
Give a very brief answer. 48.7. What is the difference between the Area (% of total land area) of Agricultural land in 2007 and the Area (% of total land area) of Permanent crop land in 2008?
Ensure brevity in your answer.  54.97. What is the difference between the Area (% of total land area) of Arable land in 2007 and the Area (% of total land area) of Permanent crop land in 2008?
Your response must be concise. 6.27. What is the difference between the Area (% of total land area) of Terrestrial protected areas in 2007 and the Area (% of total land area) of Agricultural land in 2009?
Make the answer very short. -48.37. What is the difference between the Area (% of total land area) in Terrestrial protected areas in 2007 and the Area (% of total land area) in Arable land in 2009?
Give a very brief answer. 0.29. What is the difference between the Area (% of total land area) of Terrestrial protected areas in 2007 and the Area (% of total land area) of Permanent crop land in 2009?
Your answer should be compact. 6.55. What is the difference between the Area (% of total land area) in Agricultural land in 2007 and the Area (% of total land area) in Arable land in 2009?
Provide a short and direct response. 48.7. What is the difference between the Area (% of total land area) in Agricultural land in 2007 and the Area (% of total land area) in Permanent crop land in 2009?
Make the answer very short. 54.97. What is the difference between the Area (% of total land area) in Arable land in 2007 and the Area (% of total land area) in Permanent crop land in 2009?
Your response must be concise. 6.26. What is the difference between the Area (% of total land area) in Terrestrial protected areas in 2008 and the Area (% of total land area) in Agricultural land in 2009?
Provide a succinct answer. -48.37. What is the difference between the Area (% of total land area) of Terrestrial protected areas in 2008 and the Area (% of total land area) of Arable land in 2009?
Your answer should be very brief. 0.29. What is the difference between the Area (% of total land area) of Terrestrial protected areas in 2008 and the Area (% of total land area) of Permanent crop land in 2009?
Your response must be concise. 6.55. What is the difference between the Area (% of total land area) of Agricultural land in 2008 and the Area (% of total land area) of Arable land in 2009?
Provide a short and direct response. 48.68. What is the difference between the Area (% of total land area) in Agricultural land in 2008 and the Area (% of total land area) in Permanent crop land in 2009?
Make the answer very short. 54.94. What is the difference between the Area (% of total land area) in Arable land in 2008 and the Area (% of total land area) in Permanent crop land in 2009?
Keep it short and to the point. 6.26. What is the average Area (% of total land area) of Terrestrial protected areas per year?
Ensure brevity in your answer.  6.94. What is the average Area (% of total land area) of Agricultural land per year?
Your response must be concise. 55.83. What is the average Area (% of total land area) in Arable land per year?
Keep it short and to the point. 6.74. What is the average Area (% of total land area) of Permanent crop land per year?
Offer a terse response. 0.38. In the year 2001, what is the difference between the Area (% of total land area) of Terrestrial protected areas and Area (% of total land area) of Agricultural land?
Keep it short and to the point. -49.58. In the year 2001, what is the difference between the Area (% of total land area) in Terrestrial protected areas and Area (% of total land area) in Arable land?
Ensure brevity in your answer.  -0.07. In the year 2001, what is the difference between the Area (% of total land area) in Terrestrial protected areas and Area (% of total land area) in Permanent crop land?
Provide a short and direct response. 6.59. In the year 2001, what is the difference between the Area (% of total land area) in Agricultural land and Area (% of total land area) in Arable land?
Ensure brevity in your answer.  49.51. In the year 2001, what is the difference between the Area (% of total land area) of Agricultural land and Area (% of total land area) of Permanent crop land?
Ensure brevity in your answer.  56.17. In the year 2001, what is the difference between the Area (% of total land area) of Arable land and Area (% of total land area) of Permanent crop land?
Offer a very short reply. 6.66. In the year 2002, what is the difference between the Area (% of total land area) in Terrestrial protected areas and Area (% of total land area) in Agricultural land?
Your answer should be compact. -49.21. In the year 2002, what is the difference between the Area (% of total land area) of Terrestrial protected areas and Area (% of total land area) of Arable land?
Offer a very short reply. -0.01. In the year 2002, what is the difference between the Area (% of total land area) of Terrestrial protected areas and Area (% of total land area) of Permanent crop land?
Give a very brief answer. 6.57. In the year 2002, what is the difference between the Area (% of total land area) of Agricultural land and Area (% of total land area) of Arable land?
Offer a terse response. 49.2. In the year 2002, what is the difference between the Area (% of total land area) of Agricultural land and Area (% of total land area) of Permanent crop land?
Provide a succinct answer. 55.78. In the year 2002, what is the difference between the Area (% of total land area) in Arable land and Area (% of total land area) in Permanent crop land?
Make the answer very short. 6.58. In the year 2003, what is the difference between the Area (% of total land area) of Terrestrial protected areas and Area (% of total land area) of Agricultural land?
Your answer should be very brief. -49.08. In the year 2003, what is the difference between the Area (% of total land area) of Terrestrial protected areas and Area (% of total land area) of Arable land?
Offer a terse response. 0.25. In the year 2003, what is the difference between the Area (% of total land area) in Terrestrial protected areas and Area (% of total land area) in Permanent crop land?
Give a very brief answer. 6.57. In the year 2003, what is the difference between the Area (% of total land area) in Agricultural land and Area (% of total land area) in Arable land?
Your answer should be compact. 49.33. In the year 2003, what is the difference between the Area (% of total land area) of Agricultural land and Area (% of total land area) of Permanent crop land?
Your answer should be compact. 55.65. In the year 2003, what is the difference between the Area (% of total land area) of Arable land and Area (% of total land area) of Permanent crop land?
Offer a terse response. 6.32. In the year 2004, what is the difference between the Area (% of total land area) of Terrestrial protected areas and Area (% of total land area) of Agricultural land?
Your response must be concise. -49.01. In the year 2004, what is the difference between the Area (% of total land area) in Terrestrial protected areas and Area (% of total land area) in Arable land?
Keep it short and to the point. 0.25. In the year 2004, what is the difference between the Area (% of total land area) in Terrestrial protected areas and Area (% of total land area) in Permanent crop land?
Your answer should be compact. 6.57. In the year 2004, what is the difference between the Area (% of total land area) in Agricultural land and Area (% of total land area) in Arable land?
Give a very brief answer. 49.26. In the year 2004, what is the difference between the Area (% of total land area) in Agricultural land and Area (% of total land area) in Permanent crop land?
Provide a short and direct response. 55.57. In the year 2004, what is the difference between the Area (% of total land area) of Arable land and Area (% of total land area) of Permanent crop land?
Offer a terse response. 6.32. In the year 2005, what is the difference between the Area (% of total land area) in Terrestrial protected areas and Area (% of total land area) in Agricultural land?
Your response must be concise. -48.99. In the year 2005, what is the difference between the Area (% of total land area) of Terrestrial protected areas and Area (% of total land area) of Arable land?
Provide a short and direct response. 0.27. In the year 2005, what is the difference between the Area (% of total land area) of Terrestrial protected areas and Area (% of total land area) of Permanent crop land?
Provide a short and direct response. 6.56. In the year 2005, what is the difference between the Area (% of total land area) of Agricultural land and Area (% of total land area) of Arable land?
Offer a very short reply. 49.26. In the year 2005, what is the difference between the Area (% of total land area) of Agricultural land and Area (% of total land area) of Permanent crop land?
Offer a terse response. 55.55. In the year 2005, what is the difference between the Area (% of total land area) in Arable land and Area (% of total land area) in Permanent crop land?
Give a very brief answer. 6.29. In the year 2006, what is the difference between the Area (% of total land area) in Terrestrial protected areas and Area (% of total land area) in Agricultural land?
Offer a terse response. -48.99. In the year 2006, what is the difference between the Area (% of total land area) of Terrestrial protected areas and Area (% of total land area) of Arable land?
Your answer should be compact. 0.27. In the year 2006, what is the difference between the Area (% of total land area) of Terrestrial protected areas and Area (% of total land area) of Permanent crop land?
Your response must be concise. 6.56. In the year 2006, what is the difference between the Area (% of total land area) of Agricultural land and Area (% of total land area) of Arable land?
Provide a short and direct response. 49.26. In the year 2006, what is the difference between the Area (% of total land area) of Agricultural land and Area (% of total land area) of Permanent crop land?
Offer a very short reply. 55.55. In the year 2006, what is the difference between the Area (% of total land area) in Arable land and Area (% of total land area) in Permanent crop land?
Keep it short and to the point. 6.29. In the year 2007, what is the difference between the Area (% of total land area) in Terrestrial protected areas and Area (% of total land area) in Agricultural land?
Ensure brevity in your answer.  -48.41. In the year 2007, what is the difference between the Area (% of total land area) in Terrestrial protected areas and Area (% of total land area) in Arable land?
Provide a short and direct response. 0.29. In the year 2007, what is the difference between the Area (% of total land area) of Terrestrial protected areas and Area (% of total land area) of Permanent crop land?
Provide a short and direct response. 6.55. In the year 2007, what is the difference between the Area (% of total land area) of Agricultural land and Area (% of total land area) of Arable land?
Make the answer very short. 48.7. In the year 2007, what is the difference between the Area (% of total land area) in Agricultural land and Area (% of total land area) in Permanent crop land?
Your answer should be very brief. 54.97. In the year 2007, what is the difference between the Area (% of total land area) in Arable land and Area (% of total land area) in Permanent crop land?
Keep it short and to the point. 6.26. In the year 2008, what is the difference between the Area (% of total land area) in Terrestrial protected areas and Area (% of total land area) in Agricultural land?
Your response must be concise. -48.39. In the year 2008, what is the difference between the Area (% of total land area) of Terrestrial protected areas and Area (% of total land area) of Arable land?
Your response must be concise. 0.29. In the year 2008, what is the difference between the Area (% of total land area) of Terrestrial protected areas and Area (% of total land area) of Permanent crop land?
Provide a succinct answer. 6.55. In the year 2008, what is the difference between the Area (% of total land area) in Agricultural land and Area (% of total land area) in Arable land?
Make the answer very short. 48.67. In the year 2008, what is the difference between the Area (% of total land area) of Agricultural land and Area (% of total land area) of Permanent crop land?
Your answer should be compact. 54.94. In the year 2008, what is the difference between the Area (% of total land area) in Arable land and Area (% of total land area) in Permanent crop land?
Your answer should be very brief. 6.27. In the year 2009, what is the difference between the Area (% of total land area) of Terrestrial protected areas and Area (% of total land area) of Agricultural land?
Offer a terse response. -48.37. In the year 2009, what is the difference between the Area (% of total land area) of Terrestrial protected areas and Area (% of total land area) of Arable land?
Offer a terse response. 0.29. In the year 2009, what is the difference between the Area (% of total land area) in Terrestrial protected areas and Area (% of total land area) in Permanent crop land?
Your answer should be compact. 6.55. In the year 2009, what is the difference between the Area (% of total land area) of Agricultural land and Area (% of total land area) of Arable land?
Your answer should be compact. 48.66. In the year 2009, what is the difference between the Area (% of total land area) in Agricultural land and Area (% of total land area) in Permanent crop land?
Provide a succinct answer. 54.92. In the year 2009, what is the difference between the Area (% of total land area) in Arable land and Area (% of total land area) in Permanent crop land?
Your response must be concise. 6.26. What is the ratio of the Area (% of total land area) in Terrestrial protected areas in 2001 to that in 2002?
Your answer should be compact. 1. What is the ratio of the Area (% of total land area) of Agricultural land in 2001 to that in 2002?
Offer a very short reply. 1.01. What is the ratio of the Area (% of total land area) of Arable land in 2001 to that in 2002?
Keep it short and to the point. 1.01. What is the ratio of the Area (% of total land area) in Permanent crop land in 2001 to that in 2002?
Give a very brief answer. 0.93. What is the ratio of the Area (% of total land area) in Agricultural land in 2001 to that in 2003?
Make the answer very short. 1.01. What is the ratio of the Area (% of total land area) in Arable land in 2001 to that in 2003?
Your answer should be compact. 1.05. What is the ratio of the Area (% of total land area) in Permanent crop land in 2001 to that in 2003?
Make the answer very short. 0.93. What is the ratio of the Area (% of total land area) of Agricultural land in 2001 to that in 2004?
Provide a short and direct response. 1.01. What is the ratio of the Area (% of total land area) in Arable land in 2001 to that in 2004?
Make the answer very short. 1.05. What is the ratio of the Area (% of total land area) of Permanent crop land in 2001 to that in 2004?
Give a very brief answer. 0.93. What is the ratio of the Area (% of total land area) in Terrestrial protected areas in 2001 to that in 2005?
Make the answer very short. 1. What is the ratio of the Area (% of total land area) of Agricultural land in 2001 to that in 2005?
Your response must be concise. 1.01. What is the ratio of the Area (% of total land area) of Arable land in 2001 to that in 2005?
Provide a succinct answer. 1.05. What is the ratio of the Area (% of total land area) in Permanent crop land in 2001 to that in 2005?
Your response must be concise. 0.91. What is the ratio of the Area (% of total land area) of Agricultural land in 2001 to that in 2006?
Keep it short and to the point. 1.01. What is the ratio of the Area (% of total land area) of Arable land in 2001 to that in 2006?
Give a very brief answer. 1.05. What is the ratio of the Area (% of total land area) in Permanent crop land in 2001 to that in 2006?
Provide a succinct answer. 0.91. What is the ratio of the Area (% of total land area) of Agricultural land in 2001 to that in 2007?
Give a very brief answer. 1.02. What is the ratio of the Area (% of total land area) in Arable land in 2001 to that in 2007?
Your answer should be very brief. 1.05. What is the ratio of the Area (% of total land area) of Permanent crop land in 2001 to that in 2007?
Provide a succinct answer. 0.89. What is the ratio of the Area (% of total land area) in Agricultural land in 2001 to that in 2008?
Make the answer very short. 1.02. What is the ratio of the Area (% of total land area) of Arable land in 2001 to that in 2008?
Your response must be concise. 1.05. What is the ratio of the Area (% of total land area) in Permanent crop land in 2001 to that in 2008?
Ensure brevity in your answer.  0.9. What is the ratio of the Area (% of total land area) in Terrestrial protected areas in 2001 to that in 2009?
Ensure brevity in your answer.  1. What is the ratio of the Area (% of total land area) of Agricultural land in 2001 to that in 2009?
Give a very brief answer. 1.02. What is the ratio of the Area (% of total land area) of Arable land in 2001 to that in 2009?
Ensure brevity in your answer.  1.05. What is the ratio of the Area (% of total land area) of Permanent crop land in 2001 to that in 2009?
Provide a short and direct response. 0.9. What is the ratio of the Area (% of total land area) of Terrestrial protected areas in 2002 to that in 2003?
Your answer should be compact. 1. What is the ratio of the Area (% of total land area) of Arable land in 2002 to that in 2003?
Provide a short and direct response. 1.04. What is the ratio of the Area (% of total land area) in Arable land in 2002 to that in 2004?
Offer a very short reply. 1.04. What is the ratio of the Area (% of total land area) of Terrestrial protected areas in 2002 to that in 2005?
Offer a terse response. 1. What is the ratio of the Area (% of total land area) in Arable land in 2002 to that in 2005?
Keep it short and to the point. 1.04. What is the ratio of the Area (% of total land area) in Permanent crop land in 2002 to that in 2005?
Ensure brevity in your answer.  0.98. What is the ratio of the Area (% of total land area) in Terrestrial protected areas in 2002 to that in 2006?
Provide a succinct answer. 1. What is the ratio of the Area (% of total land area) in Arable land in 2002 to that in 2006?
Provide a short and direct response. 1.04. What is the ratio of the Area (% of total land area) in Permanent crop land in 2002 to that in 2006?
Your answer should be compact. 0.98. What is the ratio of the Area (% of total land area) in Agricultural land in 2002 to that in 2007?
Your answer should be very brief. 1.01. What is the ratio of the Area (% of total land area) in Arable land in 2002 to that in 2007?
Give a very brief answer. 1.05. What is the ratio of the Area (% of total land area) of Terrestrial protected areas in 2002 to that in 2008?
Your response must be concise. 1. What is the ratio of the Area (% of total land area) of Agricultural land in 2002 to that in 2008?
Your answer should be very brief. 1.01. What is the ratio of the Area (% of total land area) of Arable land in 2002 to that in 2008?
Give a very brief answer. 1.05. What is the ratio of the Area (% of total land area) of Permanent crop land in 2002 to that in 2008?
Provide a succinct answer. 0.97. What is the ratio of the Area (% of total land area) in Agricultural land in 2002 to that in 2009?
Your response must be concise. 1.02. What is the ratio of the Area (% of total land area) in Arable land in 2002 to that in 2009?
Provide a short and direct response. 1.05. What is the ratio of the Area (% of total land area) in Permanent crop land in 2002 to that in 2009?
Your response must be concise. 0.96. What is the ratio of the Area (% of total land area) in Arable land in 2003 to that in 2004?
Offer a very short reply. 1. What is the ratio of the Area (% of total land area) in Agricultural land in 2003 to that in 2005?
Offer a terse response. 1. What is the ratio of the Area (% of total land area) of Arable land in 2003 to that in 2005?
Your response must be concise. 1. What is the ratio of the Area (% of total land area) of Permanent crop land in 2003 to that in 2005?
Provide a succinct answer. 0.98. What is the ratio of the Area (% of total land area) in Terrestrial protected areas in 2003 to that in 2006?
Make the answer very short. 1. What is the ratio of the Area (% of total land area) in Arable land in 2003 to that in 2006?
Your answer should be very brief. 1. What is the ratio of the Area (% of total land area) of Permanent crop land in 2003 to that in 2006?
Give a very brief answer. 0.98. What is the ratio of the Area (% of total land area) in Agricultural land in 2003 to that in 2007?
Ensure brevity in your answer.  1.01. What is the ratio of the Area (% of total land area) of Arable land in 2003 to that in 2007?
Your response must be concise. 1.01. What is the ratio of the Area (% of total land area) in Permanent crop land in 2003 to that in 2007?
Ensure brevity in your answer.  0.96. What is the ratio of the Area (% of total land area) in Agricultural land in 2003 to that in 2008?
Your response must be concise. 1.01. What is the ratio of the Area (% of total land area) of Permanent crop land in 2003 to that in 2008?
Keep it short and to the point. 0.97. What is the ratio of the Area (% of total land area) of Agricultural land in 2003 to that in 2009?
Ensure brevity in your answer.  1.01. What is the ratio of the Area (% of total land area) in Permanent crop land in 2003 to that in 2009?
Make the answer very short. 0.96. What is the ratio of the Area (% of total land area) of Agricultural land in 2004 to that in 2005?
Ensure brevity in your answer.  1. What is the ratio of the Area (% of total land area) of Permanent crop land in 2004 to that in 2005?
Offer a very short reply. 0.98. What is the ratio of the Area (% of total land area) of Terrestrial protected areas in 2004 to that in 2006?
Make the answer very short. 1. What is the ratio of the Area (% of total land area) in Agricultural land in 2004 to that in 2006?
Make the answer very short. 1. What is the ratio of the Area (% of total land area) of Permanent crop land in 2004 to that in 2006?
Provide a short and direct response. 0.98. What is the ratio of the Area (% of total land area) of Agricultural land in 2004 to that in 2007?
Offer a very short reply. 1.01. What is the ratio of the Area (% of total land area) of Arable land in 2004 to that in 2007?
Make the answer very short. 1.01. What is the ratio of the Area (% of total land area) in Permanent crop land in 2004 to that in 2007?
Offer a very short reply. 0.96. What is the ratio of the Area (% of total land area) of Terrestrial protected areas in 2004 to that in 2008?
Give a very brief answer. 1. What is the ratio of the Area (% of total land area) of Agricultural land in 2004 to that in 2008?
Make the answer very short. 1.01. What is the ratio of the Area (% of total land area) in Arable land in 2004 to that in 2008?
Provide a succinct answer. 1.01. What is the ratio of the Area (% of total land area) in Permanent crop land in 2004 to that in 2008?
Make the answer very short. 0.97. What is the ratio of the Area (% of total land area) of Agricultural land in 2004 to that in 2009?
Provide a short and direct response. 1.01. What is the ratio of the Area (% of total land area) in Permanent crop land in 2004 to that in 2009?
Keep it short and to the point. 0.96. What is the ratio of the Area (% of total land area) of Terrestrial protected areas in 2005 to that in 2006?
Give a very brief answer. 1. What is the ratio of the Area (% of total land area) in Terrestrial protected areas in 2005 to that in 2007?
Offer a very short reply. 1. What is the ratio of the Area (% of total land area) in Agricultural land in 2005 to that in 2007?
Offer a very short reply. 1.01. What is the ratio of the Area (% of total land area) in Arable land in 2005 to that in 2007?
Ensure brevity in your answer.  1. What is the ratio of the Area (% of total land area) in Permanent crop land in 2005 to that in 2007?
Your response must be concise. 0.98. What is the ratio of the Area (% of total land area) in Agricultural land in 2005 to that in 2008?
Provide a succinct answer. 1.01. What is the ratio of the Area (% of total land area) in Agricultural land in 2005 to that in 2009?
Make the answer very short. 1.01. What is the ratio of the Area (% of total land area) of Arable land in 2005 to that in 2009?
Keep it short and to the point. 1. What is the ratio of the Area (% of total land area) of Permanent crop land in 2005 to that in 2009?
Offer a terse response. 0.98. What is the ratio of the Area (% of total land area) of Terrestrial protected areas in 2006 to that in 2007?
Your answer should be very brief. 1. What is the ratio of the Area (% of total land area) in Agricultural land in 2006 to that in 2007?
Provide a succinct answer. 1.01. What is the ratio of the Area (% of total land area) in Arable land in 2006 to that in 2007?
Offer a very short reply. 1. What is the ratio of the Area (% of total land area) of Permanent crop land in 2006 to that in 2007?
Give a very brief answer. 0.98. What is the ratio of the Area (% of total land area) of Terrestrial protected areas in 2006 to that in 2008?
Your answer should be compact. 1. What is the ratio of the Area (% of total land area) in Agricultural land in 2006 to that in 2008?
Make the answer very short. 1.01. What is the ratio of the Area (% of total land area) of Permanent crop land in 2006 to that in 2008?
Your answer should be very brief. 0.99. What is the ratio of the Area (% of total land area) in Terrestrial protected areas in 2006 to that in 2009?
Provide a short and direct response. 1. What is the ratio of the Area (% of total land area) in Agricultural land in 2006 to that in 2009?
Provide a short and direct response. 1.01. What is the ratio of the Area (% of total land area) in Permanent crop land in 2006 to that in 2009?
Keep it short and to the point. 0.98. What is the ratio of the Area (% of total land area) in Terrestrial protected areas in 2007 to that in 2008?
Ensure brevity in your answer.  1. What is the ratio of the Area (% of total land area) in Arable land in 2007 to that in 2008?
Provide a short and direct response. 1. What is the ratio of the Area (% of total land area) of Permanent crop land in 2007 to that in 2008?
Keep it short and to the point. 1.01. What is the ratio of the Area (% of total land area) in Permanent crop land in 2007 to that in 2009?
Your answer should be very brief. 1. What is the ratio of the Area (% of total land area) in Agricultural land in 2008 to that in 2009?
Make the answer very short. 1. What is the ratio of the Area (% of total land area) in Arable land in 2008 to that in 2009?
Give a very brief answer. 1. What is the ratio of the Area (% of total land area) in Permanent crop land in 2008 to that in 2009?
Ensure brevity in your answer.  0.99. What is the difference between the highest and the second highest Area (% of total land area) of Terrestrial protected areas?
Offer a very short reply. 0. What is the difference between the highest and the second highest Area (% of total land area) in Agricultural land?
Keep it short and to the point. 0.36. What is the difference between the highest and the second highest Area (% of total land area) in Arable land?
Offer a terse response. 0.05. What is the difference between the highest and the second highest Area (% of total land area) in Permanent crop land?
Your answer should be compact. 0. What is the difference between the highest and the lowest Area (% of total land area) of Agricultural land?
Your response must be concise. 1.21. What is the difference between the highest and the lowest Area (% of total land area) of Arable land?
Make the answer very short. 0.36. What is the difference between the highest and the lowest Area (% of total land area) of Permanent crop land?
Your answer should be very brief. 0.04. 